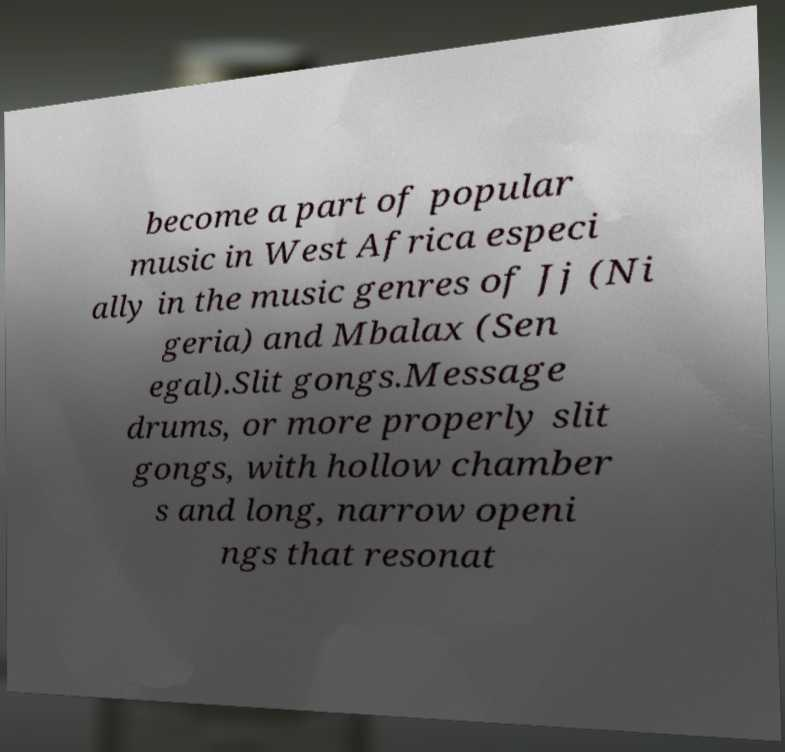Could you extract and type out the text from this image? become a part of popular music in West Africa especi ally in the music genres of Jj (Ni geria) and Mbalax (Sen egal).Slit gongs.Message drums, or more properly slit gongs, with hollow chamber s and long, narrow openi ngs that resonat 